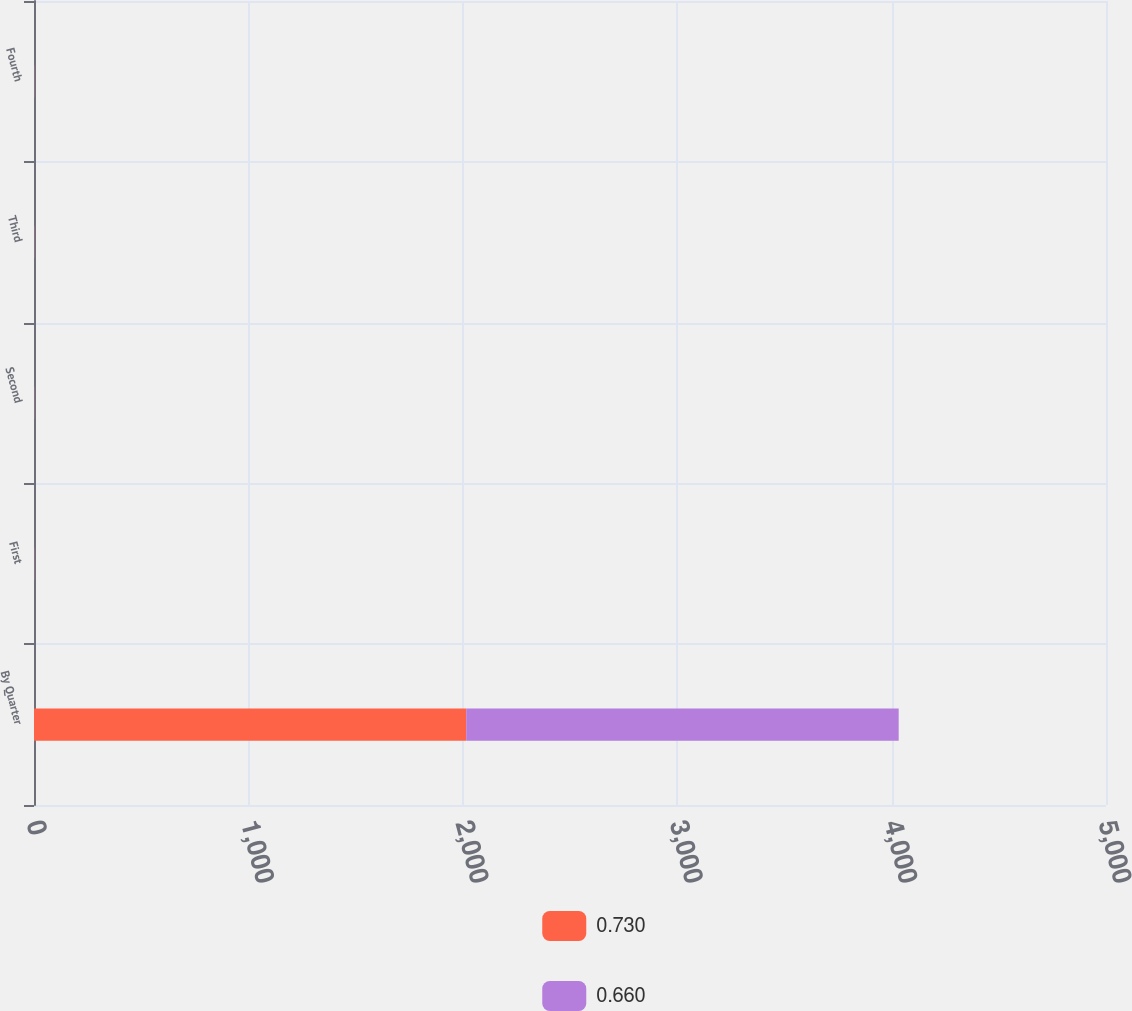Convert chart to OTSL. <chart><loc_0><loc_0><loc_500><loc_500><stacked_bar_chart><ecel><fcel>By Quarter<fcel>First<fcel>Second<fcel>Third<fcel>Fourth<nl><fcel>0.73<fcel>2016<fcel>0.66<fcel>0.66<fcel>0.66<fcel>0.66<nl><fcel>0.66<fcel>2017<fcel>0.73<fcel>0.73<fcel>0.73<fcel>0.73<nl></chart> 